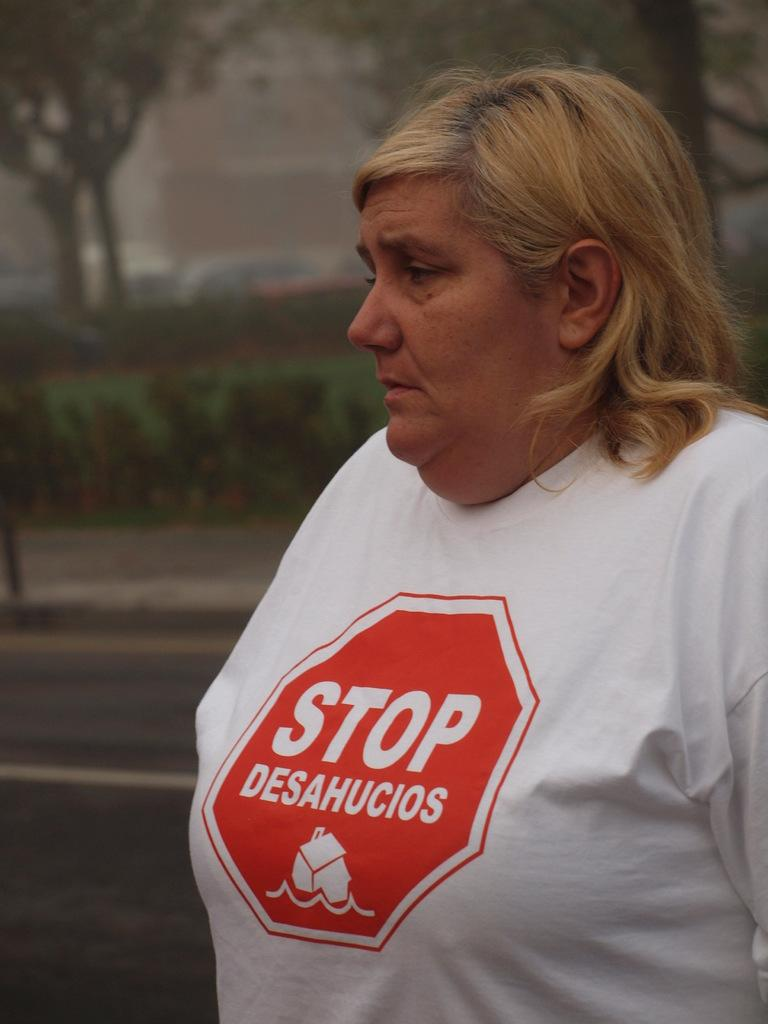Who is present on the right side of the image? There is a lady on the right side of the image. What can be seen in the background of the image? There are trees, a wall, and bushes in the background of the image. What is at the bottom of the image? There is a road at the bottom of the image. What type of reward can be seen in the image? There is no reward present in the image. Is there a volcano visible in the background of the image? No, there is no volcano present in the image. 